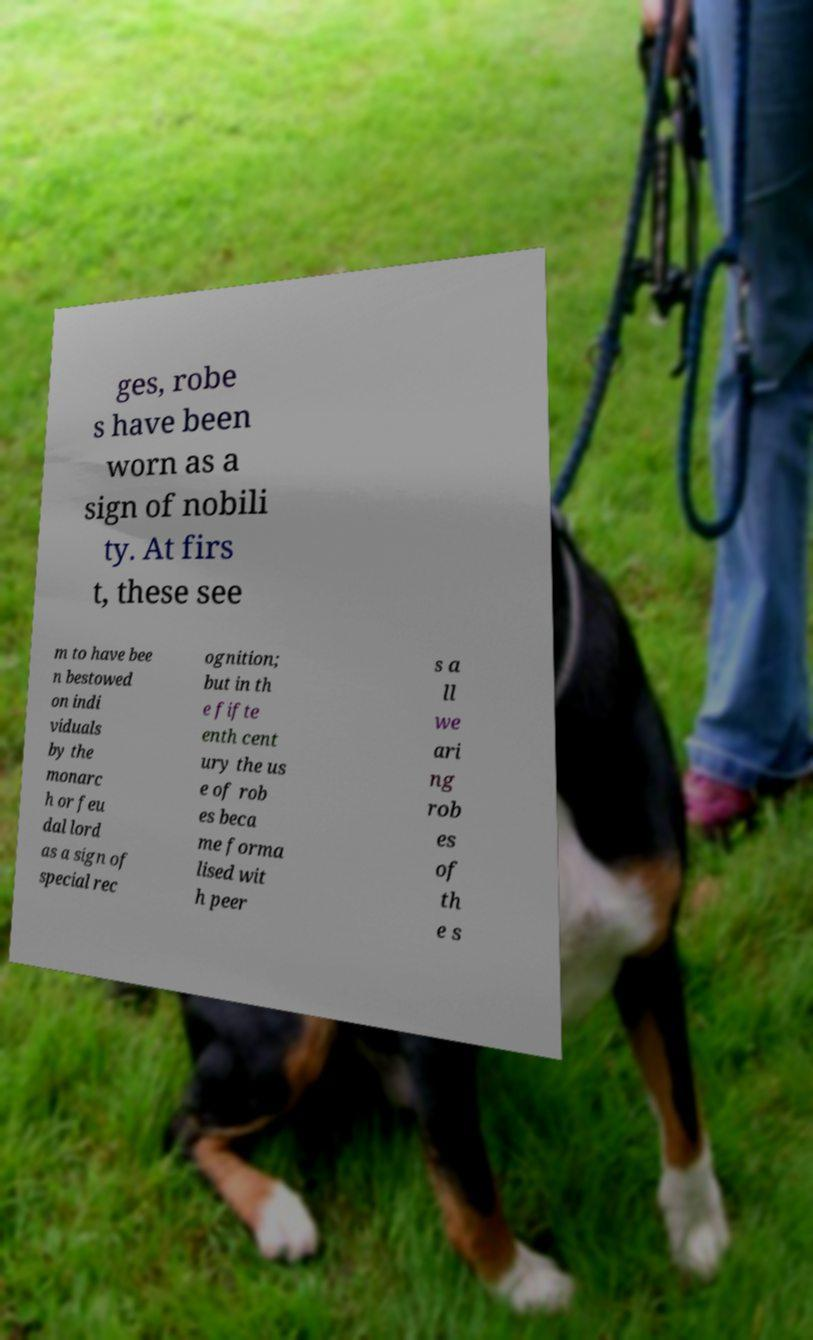Can you read and provide the text displayed in the image?This photo seems to have some interesting text. Can you extract and type it out for me? ges, robe s have been worn as a sign of nobili ty. At firs t, these see m to have bee n bestowed on indi viduals by the monarc h or feu dal lord as a sign of special rec ognition; but in th e fifte enth cent ury the us e of rob es beca me forma lised wit h peer s a ll we ari ng rob es of th e s 